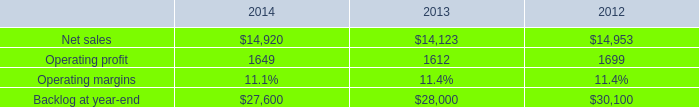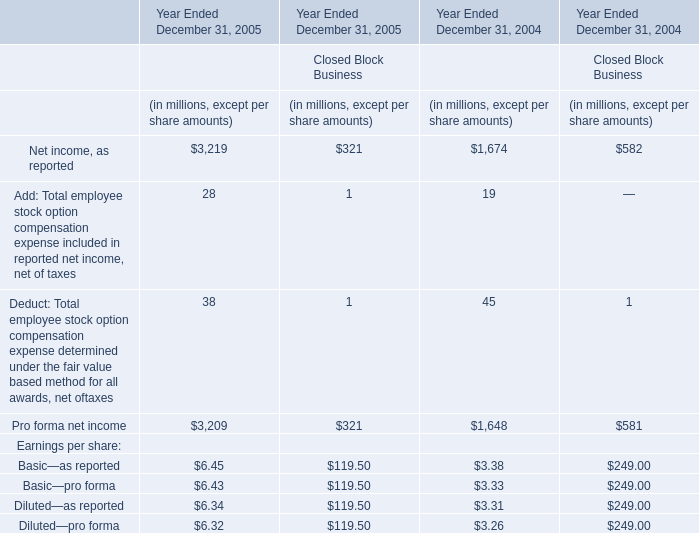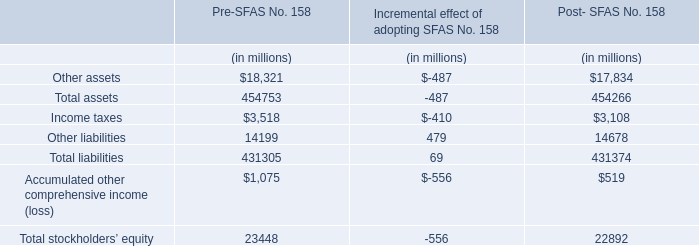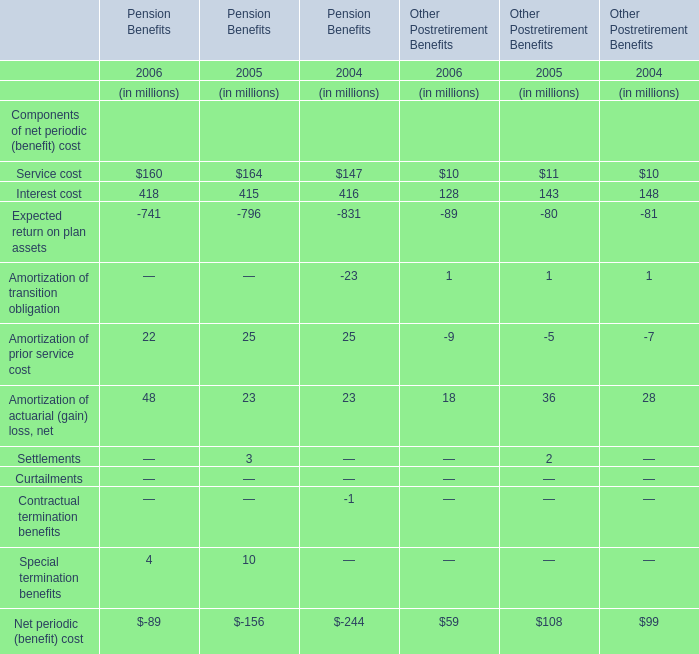What's the current increasing rate of Service cost for Pension Benefits? 
Computations: ((160 - 164) / 164)
Answer: -0.02439. 